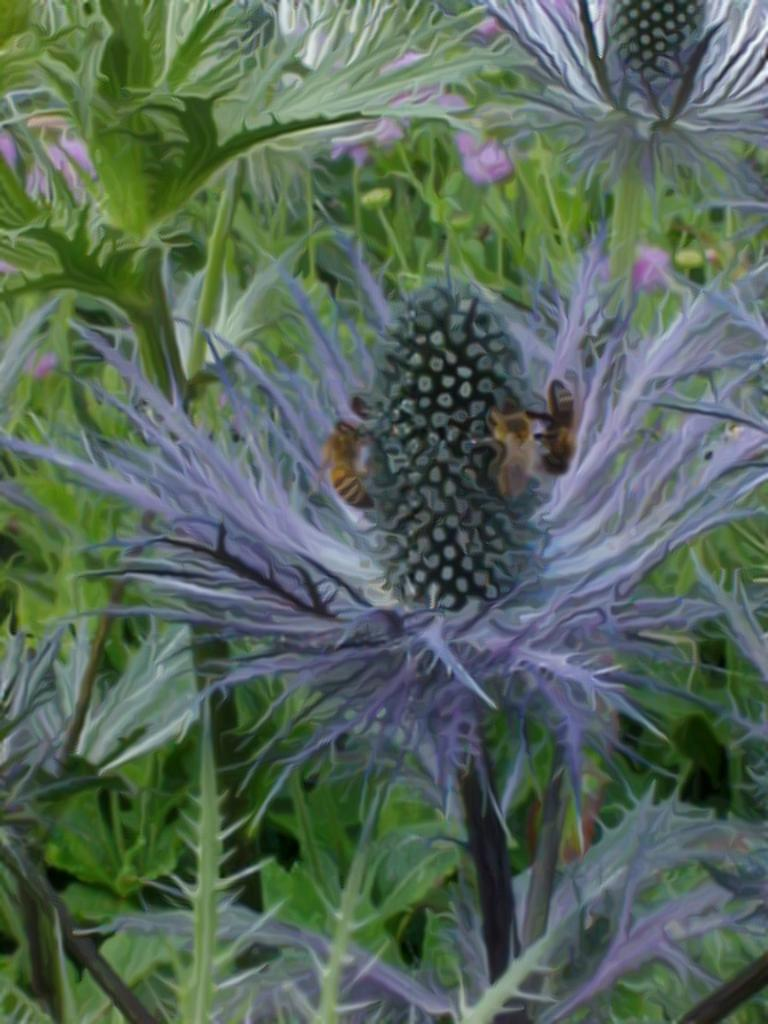What is the main subject in the middle of the image? There is a flower in the middle of the image. Can you describe the background of the image? There is a plant with flowers in the background of the image. Are there any fairies flying around the flowers in the image? There is no indication of fairies in the image; it only features flowers and plants. 